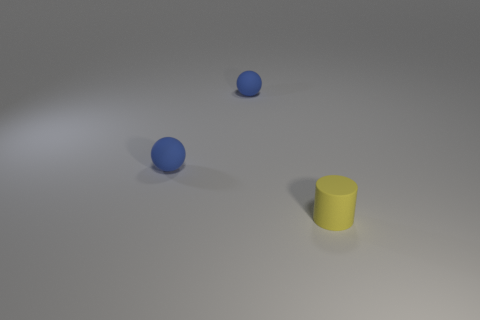How many other objects are there of the same shape as the small yellow object?
Your answer should be compact. 0. Are there any other small matte objects that have the same shape as the yellow matte thing?
Offer a very short reply. No. Are there the same number of yellow cylinders on the right side of the yellow cylinder and big cyan shiny spheres?
Provide a succinct answer. Yes. The small yellow thing has what shape?
Ensure brevity in your answer.  Cylinder. Are there more small cylinders that are left of the yellow cylinder than tiny yellow matte cylinders?
Provide a short and direct response. No. Is there a blue sphere made of the same material as the yellow cylinder?
Ensure brevity in your answer.  Yes. How many cylinders are blue matte objects or yellow objects?
Your response must be concise. 1. Is there any other thing that has the same shape as the yellow thing?
Keep it short and to the point. No. How many tiny balls are there?
Your answer should be very brief. 2. Are there any other yellow things that have the same size as the yellow thing?
Ensure brevity in your answer.  No. 